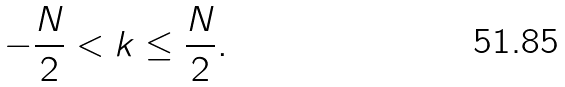Convert formula to latex. <formula><loc_0><loc_0><loc_500><loc_500>- \frac { N } { 2 } < k \leq \frac { N } { 2 } .</formula> 